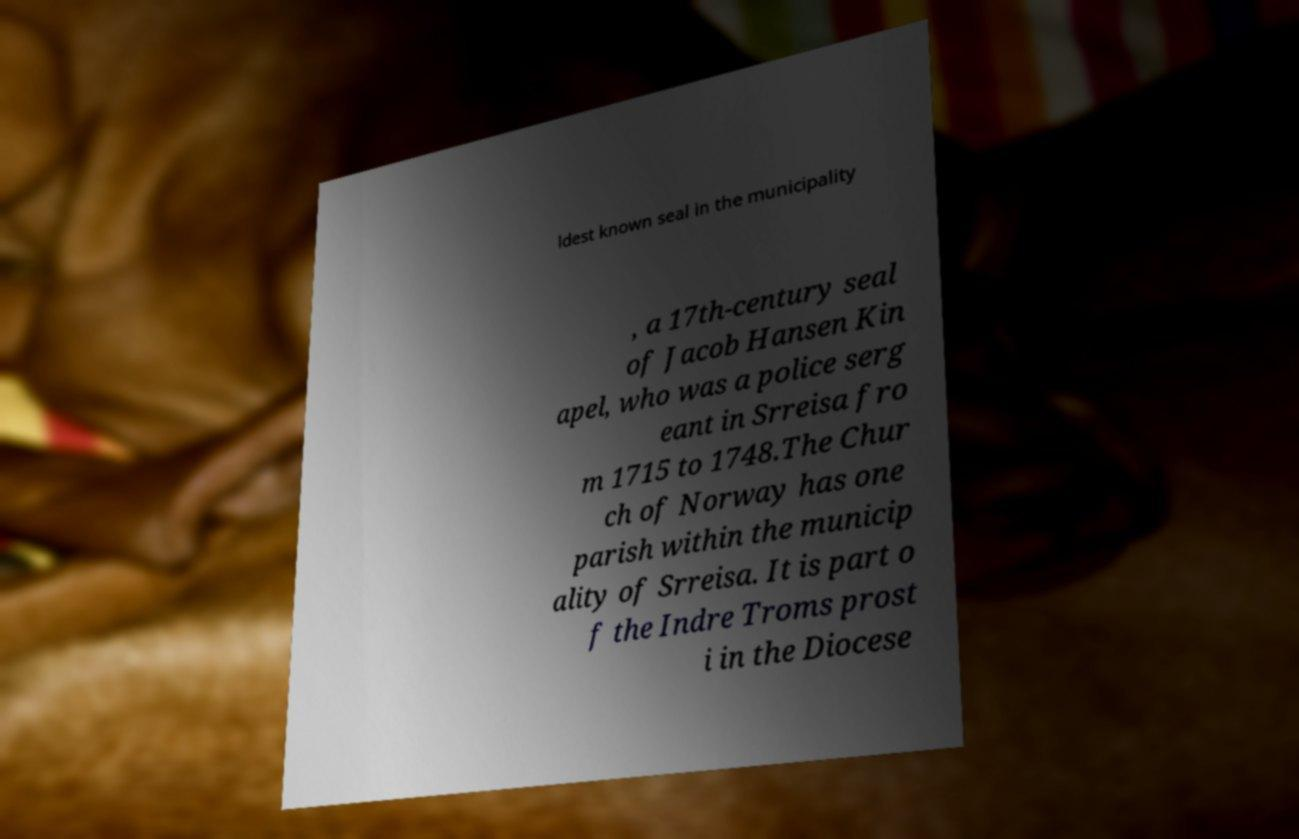Could you assist in decoding the text presented in this image and type it out clearly? ldest known seal in the municipality , a 17th-century seal of Jacob Hansen Kin apel, who was a police serg eant in Srreisa fro m 1715 to 1748.The Chur ch of Norway has one parish within the municip ality of Srreisa. It is part o f the Indre Troms prost i in the Diocese 